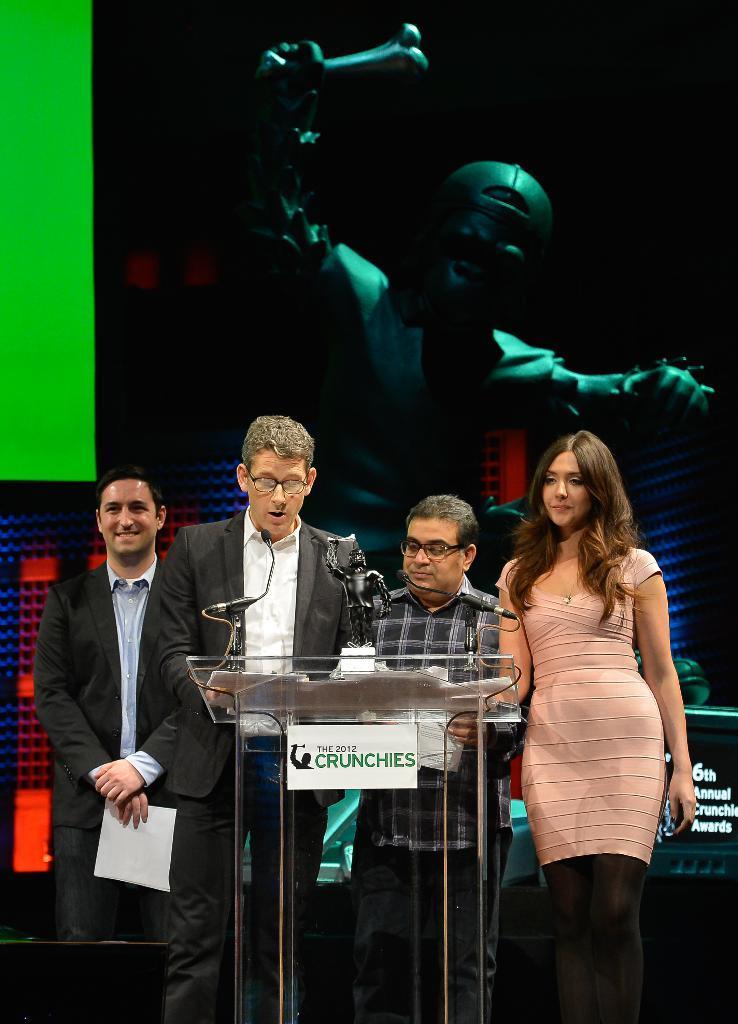Could you give a brief overview of what you see in this image? There are four persons in different color dresses, standing on a stage. One of them is speaking in front of a mic, which is attached to a stand which is on a glass stand, on which there are documents, a statue and another mic. In the background, there is a screen. 